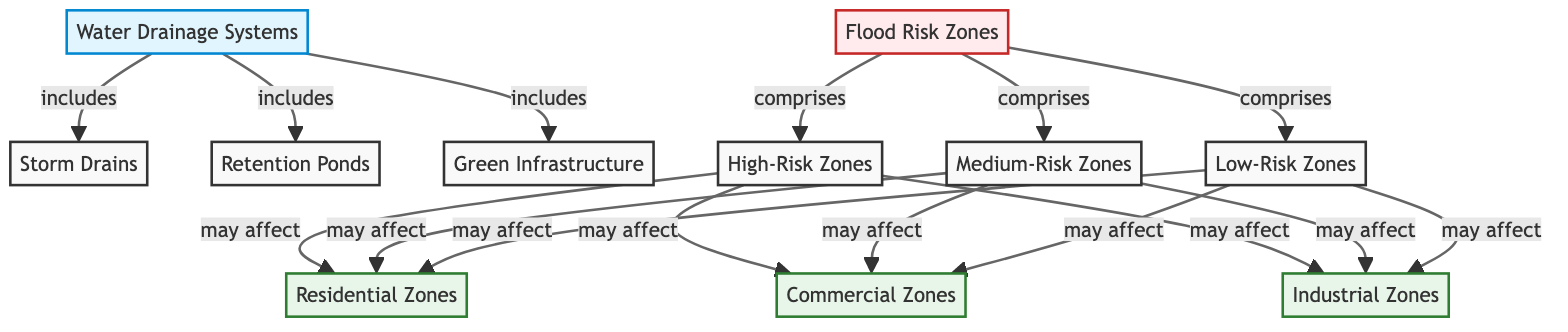What's included in the water drainage systems? The diagram indicates that the water drainage systems include storm drains, retention ponds, and green infrastructure. By looking directly at the connections branching from the "Water Drainage Systems" node, the three elements are listed clearly.
Answer: storm drains, retention ponds, green infrastructure How many flood risk zones are there? The diagram shows three distinct classifications for flood risk zones: high-risk zones, medium-risk zones, and low-risk zones. This can be confirmed by counting the nodes that stem from the "Flood Risk Zones" node.
Answer: 3 Which zoning classifications are affected by high-risk zones? The diagram reveals that high-risk zones may affect residential zones, commercial zones, and industrial zones. By tracing the connections from the high-risk node, we can see all three zoning types that are influenced.
Answer: residential zones, commercial zones, industrial zones What types of water drainage systems are in place? According to the diagram, the types of water drainage systems include storm drains, retention ponds, and green infrastructure. This is seen as part of the detailed breakdown of the main water drainage systems node.
Answer: storm drains, retention ponds, green infrastructure What is the relationship between medium-risk zones and zoning classifications? The diagram shows that medium-risk zones may affect all three zoning classifications: residential, commercial, and industrial. By observing the arrows leading from the medium-risk node to each zoning type, we can gather this information.
Answer: may affect residential, commercial, industrial zones What color represents flood risk zones? The flood risk zones are depicted in a light red color, specifically denoted by the fill color and stroke properties in the diagram. This can be confirmed by identifying the color coding used for the flood risk zones node.
Answer: light red How do low-risk zones interact with zoning classifications? The diagram indicates that low-risk zones may also affect residential zones, commercial zones, and industrial zones. This can be identified by tracing the connections from the low-risk zones node to the residential, commercial, and industrial nodes.
Answer: may affect residential, commercial, industrial zones 